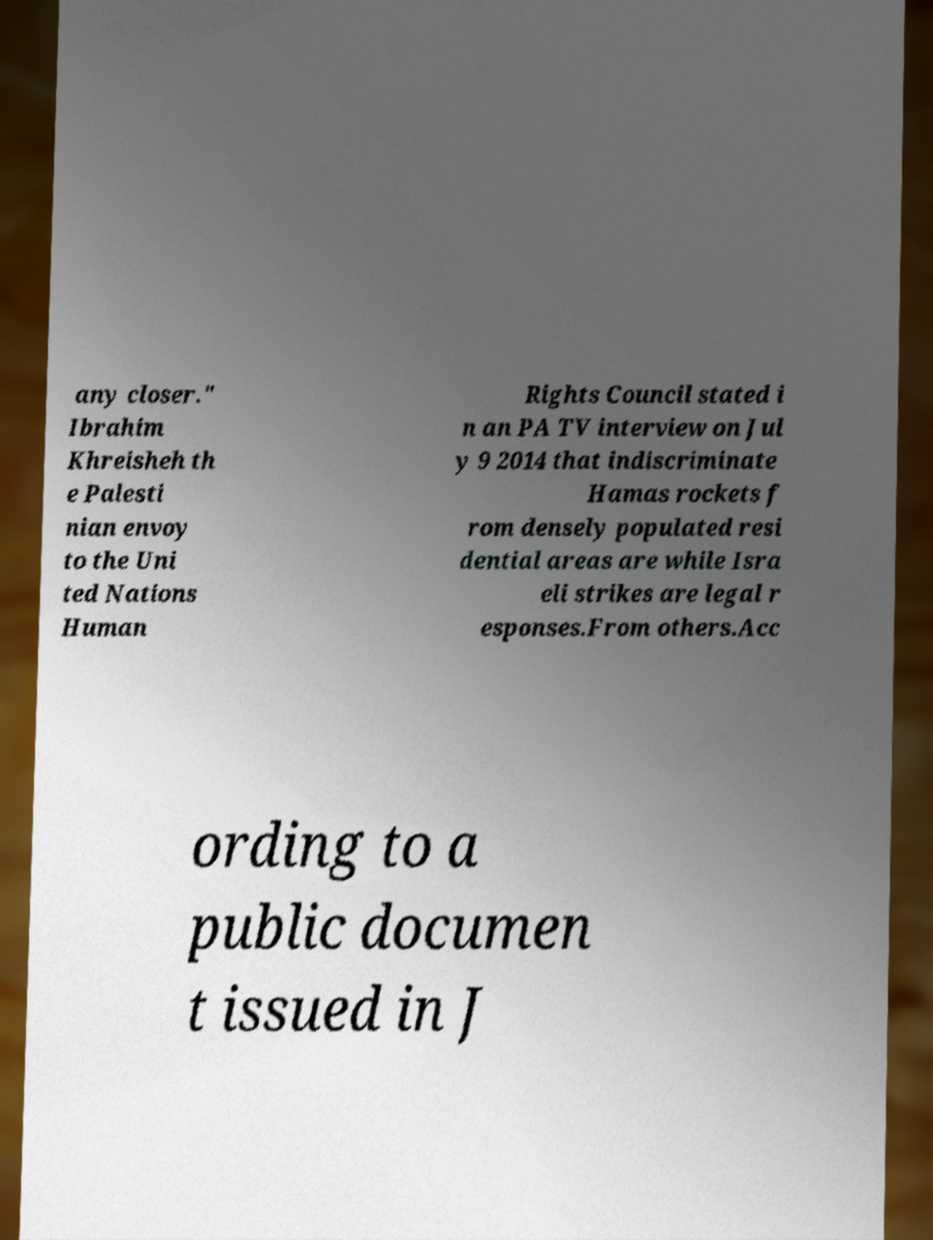Can you read and provide the text displayed in the image?This photo seems to have some interesting text. Can you extract and type it out for me? any closer." Ibrahim Khreisheh th e Palesti nian envoy to the Uni ted Nations Human Rights Council stated i n an PA TV interview on Jul y 9 2014 that indiscriminate Hamas rockets f rom densely populated resi dential areas are while Isra eli strikes are legal r esponses.From others.Acc ording to a public documen t issued in J 